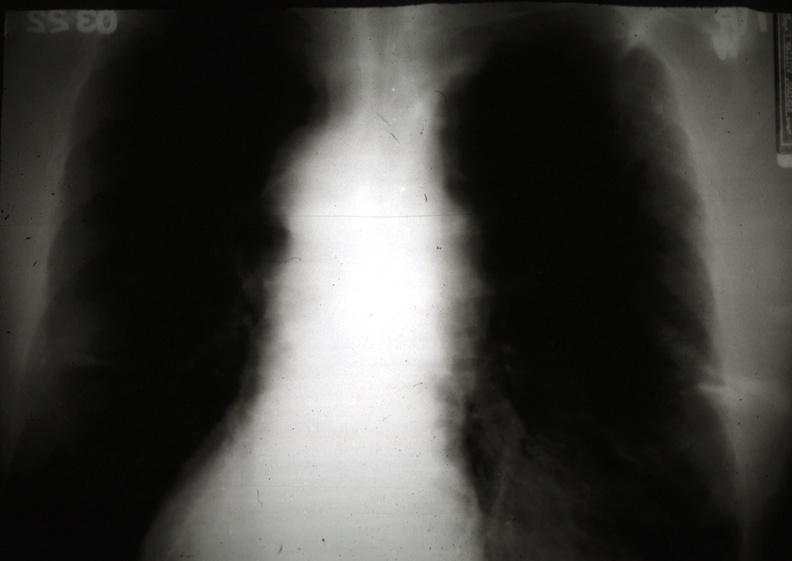what is present?
Answer the question using a single word or phrase. Malignant thymoma 